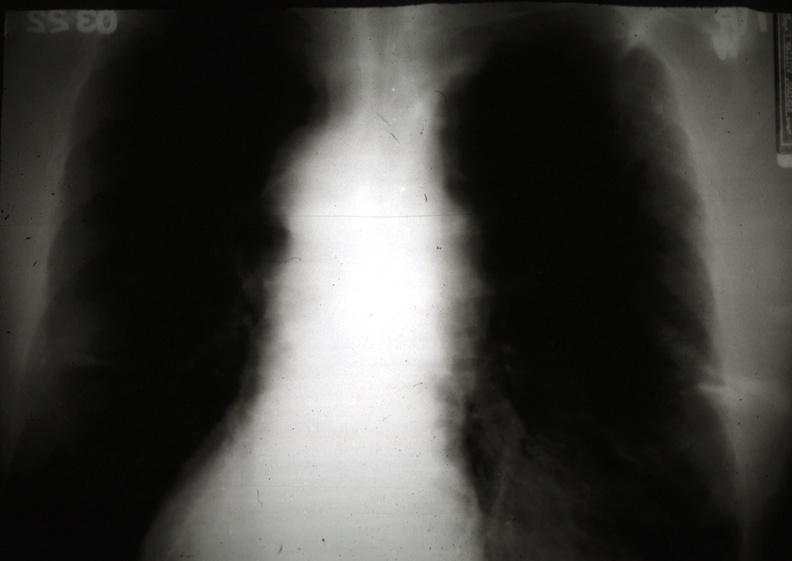what is present?
Answer the question using a single word or phrase. Malignant thymoma 